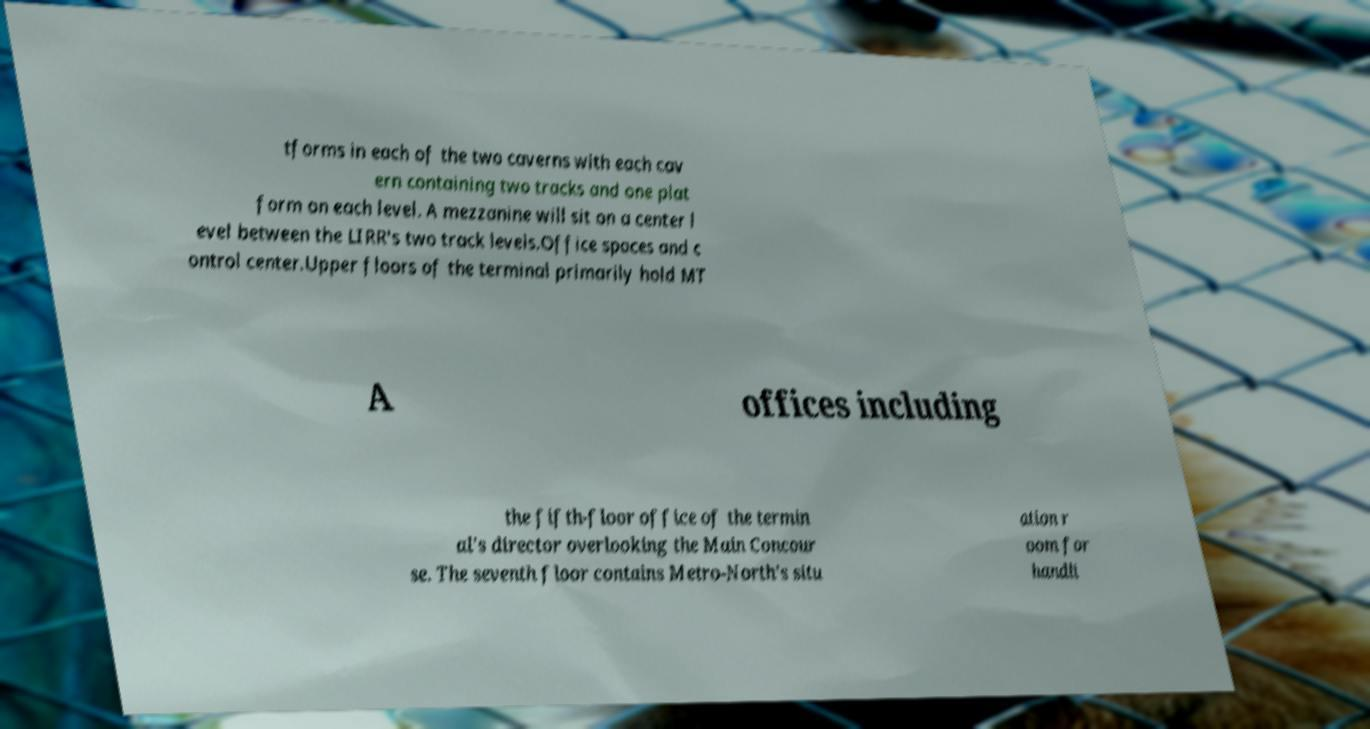There's text embedded in this image that I need extracted. Can you transcribe it verbatim? tforms in each of the two caverns with each cav ern containing two tracks and one plat form on each level. A mezzanine will sit on a center l evel between the LIRR's two track levels.Office spaces and c ontrol center.Upper floors of the terminal primarily hold MT A offices including the fifth-floor office of the termin al's director overlooking the Main Concour se. The seventh floor contains Metro-North's situ ation r oom for handli 